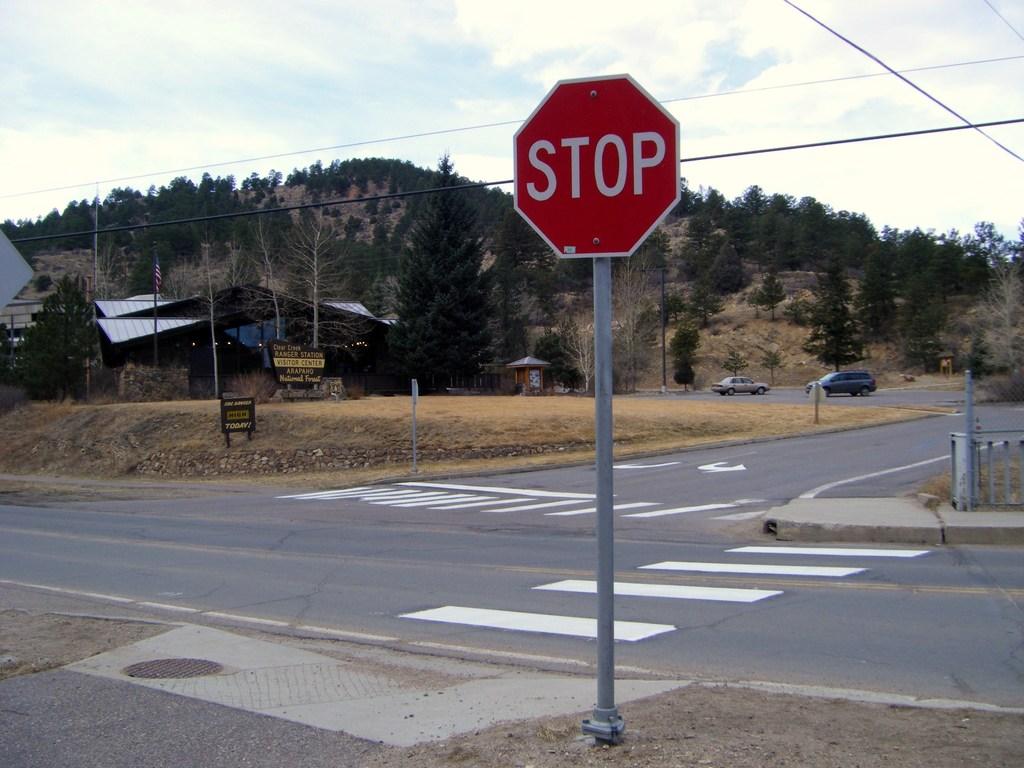What does the sign on the far left say?
Your answer should be compact. Unanswerable. 